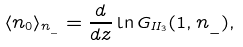Convert formula to latex. <formula><loc_0><loc_0><loc_500><loc_500>\langle n _ { 0 } \rangle _ { n _ { \_ } } = \frac { d } { d z } \ln G _ { I I _ { 3 } } ( 1 , n _ { \_ } ) ,</formula> 